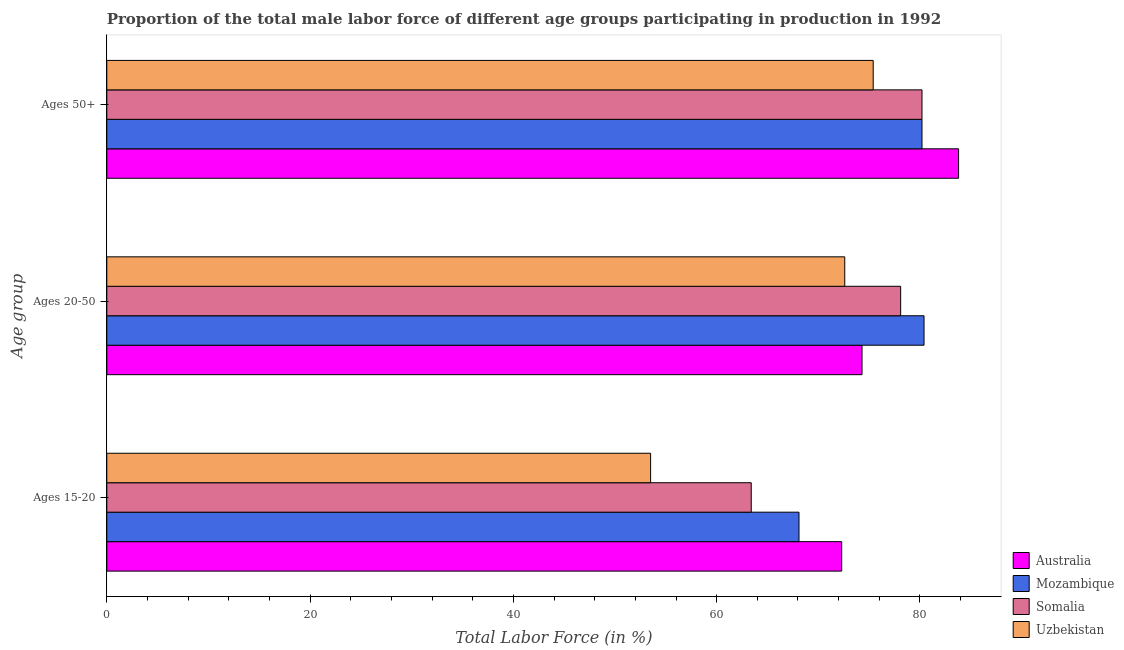How many different coloured bars are there?
Provide a succinct answer. 4. How many groups of bars are there?
Your answer should be very brief. 3. What is the label of the 3rd group of bars from the top?
Your answer should be compact. Ages 15-20. What is the percentage of male labor force above age 50 in Mozambique?
Offer a very short reply. 80.2. Across all countries, what is the maximum percentage of male labor force above age 50?
Your answer should be compact. 83.8. Across all countries, what is the minimum percentage of male labor force within the age group 20-50?
Provide a succinct answer. 72.6. In which country was the percentage of male labor force within the age group 20-50 maximum?
Provide a short and direct response. Mozambique. In which country was the percentage of male labor force within the age group 15-20 minimum?
Offer a terse response. Uzbekistan. What is the total percentage of male labor force within the age group 20-50 in the graph?
Provide a succinct answer. 305.4. What is the difference between the percentage of male labor force above age 50 in Uzbekistan and that in Australia?
Offer a terse response. -8.4. What is the difference between the percentage of male labor force within the age group 15-20 in Uzbekistan and the percentage of male labor force above age 50 in Mozambique?
Provide a succinct answer. -26.7. What is the average percentage of male labor force above age 50 per country?
Keep it short and to the point. 79.9. What is the difference between the percentage of male labor force above age 50 and percentage of male labor force within the age group 15-20 in Mozambique?
Your answer should be very brief. 12.1. In how many countries, is the percentage of male labor force above age 50 greater than 28 %?
Provide a succinct answer. 4. What is the ratio of the percentage of male labor force above age 50 in Mozambique to that in Australia?
Keep it short and to the point. 0.96. Is the percentage of male labor force within the age group 20-50 in Somalia less than that in Mozambique?
Give a very brief answer. Yes. Is the difference between the percentage of male labor force within the age group 15-20 in Australia and Mozambique greater than the difference between the percentage of male labor force above age 50 in Australia and Mozambique?
Give a very brief answer. Yes. What is the difference between the highest and the second highest percentage of male labor force above age 50?
Your response must be concise. 3.6. What is the difference between the highest and the lowest percentage of male labor force within the age group 15-20?
Give a very brief answer. 18.8. What does the 4th bar from the bottom in Ages 50+ represents?
Keep it short and to the point. Uzbekistan. Is it the case that in every country, the sum of the percentage of male labor force within the age group 15-20 and percentage of male labor force within the age group 20-50 is greater than the percentage of male labor force above age 50?
Ensure brevity in your answer.  Yes. How many bars are there?
Provide a short and direct response. 12. Are the values on the major ticks of X-axis written in scientific E-notation?
Your answer should be very brief. No. Does the graph contain any zero values?
Your answer should be compact. No. Does the graph contain grids?
Ensure brevity in your answer.  No. Where does the legend appear in the graph?
Give a very brief answer. Bottom right. How many legend labels are there?
Keep it short and to the point. 4. How are the legend labels stacked?
Your response must be concise. Vertical. What is the title of the graph?
Give a very brief answer. Proportion of the total male labor force of different age groups participating in production in 1992. Does "Turks and Caicos Islands" appear as one of the legend labels in the graph?
Offer a very short reply. No. What is the label or title of the Y-axis?
Make the answer very short. Age group. What is the Total Labor Force (in %) in Australia in Ages 15-20?
Provide a succinct answer. 72.3. What is the Total Labor Force (in %) in Mozambique in Ages 15-20?
Your response must be concise. 68.1. What is the Total Labor Force (in %) of Somalia in Ages 15-20?
Provide a succinct answer. 63.4. What is the Total Labor Force (in %) in Uzbekistan in Ages 15-20?
Make the answer very short. 53.5. What is the Total Labor Force (in %) in Australia in Ages 20-50?
Give a very brief answer. 74.3. What is the Total Labor Force (in %) in Mozambique in Ages 20-50?
Provide a short and direct response. 80.4. What is the Total Labor Force (in %) of Somalia in Ages 20-50?
Offer a terse response. 78.1. What is the Total Labor Force (in %) of Uzbekistan in Ages 20-50?
Provide a short and direct response. 72.6. What is the Total Labor Force (in %) in Australia in Ages 50+?
Your response must be concise. 83.8. What is the Total Labor Force (in %) of Mozambique in Ages 50+?
Keep it short and to the point. 80.2. What is the Total Labor Force (in %) in Somalia in Ages 50+?
Keep it short and to the point. 80.2. What is the Total Labor Force (in %) of Uzbekistan in Ages 50+?
Your answer should be very brief. 75.4. Across all Age group, what is the maximum Total Labor Force (in %) in Australia?
Your answer should be very brief. 83.8. Across all Age group, what is the maximum Total Labor Force (in %) of Mozambique?
Offer a terse response. 80.4. Across all Age group, what is the maximum Total Labor Force (in %) in Somalia?
Your answer should be compact. 80.2. Across all Age group, what is the maximum Total Labor Force (in %) of Uzbekistan?
Provide a succinct answer. 75.4. Across all Age group, what is the minimum Total Labor Force (in %) of Australia?
Offer a terse response. 72.3. Across all Age group, what is the minimum Total Labor Force (in %) in Mozambique?
Offer a very short reply. 68.1. Across all Age group, what is the minimum Total Labor Force (in %) of Somalia?
Provide a succinct answer. 63.4. Across all Age group, what is the minimum Total Labor Force (in %) in Uzbekistan?
Your response must be concise. 53.5. What is the total Total Labor Force (in %) of Australia in the graph?
Provide a succinct answer. 230.4. What is the total Total Labor Force (in %) of Mozambique in the graph?
Your response must be concise. 228.7. What is the total Total Labor Force (in %) of Somalia in the graph?
Your answer should be compact. 221.7. What is the total Total Labor Force (in %) in Uzbekistan in the graph?
Provide a short and direct response. 201.5. What is the difference between the Total Labor Force (in %) of Australia in Ages 15-20 and that in Ages 20-50?
Offer a terse response. -2. What is the difference between the Total Labor Force (in %) of Mozambique in Ages 15-20 and that in Ages 20-50?
Provide a short and direct response. -12.3. What is the difference between the Total Labor Force (in %) of Somalia in Ages 15-20 and that in Ages 20-50?
Make the answer very short. -14.7. What is the difference between the Total Labor Force (in %) in Uzbekistan in Ages 15-20 and that in Ages 20-50?
Your response must be concise. -19.1. What is the difference between the Total Labor Force (in %) in Australia in Ages 15-20 and that in Ages 50+?
Provide a succinct answer. -11.5. What is the difference between the Total Labor Force (in %) in Mozambique in Ages 15-20 and that in Ages 50+?
Give a very brief answer. -12.1. What is the difference between the Total Labor Force (in %) of Somalia in Ages 15-20 and that in Ages 50+?
Offer a very short reply. -16.8. What is the difference between the Total Labor Force (in %) in Uzbekistan in Ages 15-20 and that in Ages 50+?
Ensure brevity in your answer.  -21.9. What is the difference between the Total Labor Force (in %) in Somalia in Ages 20-50 and that in Ages 50+?
Provide a succinct answer. -2.1. What is the difference between the Total Labor Force (in %) of Uzbekistan in Ages 20-50 and that in Ages 50+?
Offer a terse response. -2.8. What is the difference between the Total Labor Force (in %) of Australia in Ages 15-20 and the Total Labor Force (in %) of Mozambique in Ages 20-50?
Ensure brevity in your answer.  -8.1. What is the difference between the Total Labor Force (in %) of Australia in Ages 15-20 and the Total Labor Force (in %) of Somalia in Ages 20-50?
Offer a terse response. -5.8. What is the difference between the Total Labor Force (in %) of Mozambique in Ages 15-20 and the Total Labor Force (in %) of Uzbekistan in Ages 20-50?
Ensure brevity in your answer.  -4.5. What is the difference between the Total Labor Force (in %) in Australia in Ages 15-20 and the Total Labor Force (in %) in Mozambique in Ages 50+?
Make the answer very short. -7.9. What is the difference between the Total Labor Force (in %) in Australia in Ages 15-20 and the Total Labor Force (in %) in Somalia in Ages 50+?
Provide a succinct answer. -7.9. What is the difference between the Total Labor Force (in %) of Australia in Ages 15-20 and the Total Labor Force (in %) of Uzbekistan in Ages 50+?
Your answer should be compact. -3.1. What is the difference between the Total Labor Force (in %) in Mozambique in Ages 15-20 and the Total Labor Force (in %) in Somalia in Ages 50+?
Your response must be concise. -12.1. What is the difference between the Total Labor Force (in %) in Mozambique in Ages 15-20 and the Total Labor Force (in %) in Uzbekistan in Ages 50+?
Ensure brevity in your answer.  -7.3. What is the difference between the Total Labor Force (in %) of Somalia in Ages 15-20 and the Total Labor Force (in %) of Uzbekistan in Ages 50+?
Your answer should be very brief. -12. What is the difference between the Total Labor Force (in %) of Mozambique in Ages 20-50 and the Total Labor Force (in %) of Somalia in Ages 50+?
Offer a very short reply. 0.2. What is the difference between the Total Labor Force (in %) of Somalia in Ages 20-50 and the Total Labor Force (in %) of Uzbekistan in Ages 50+?
Provide a short and direct response. 2.7. What is the average Total Labor Force (in %) in Australia per Age group?
Offer a terse response. 76.8. What is the average Total Labor Force (in %) in Mozambique per Age group?
Your answer should be very brief. 76.23. What is the average Total Labor Force (in %) in Somalia per Age group?
Give a very brief answer. 73.9. What is the average Total Labor Force (in %) of Uzbekistan per Age group?
Give a very brief answer. 67.17. What is the difference between the Total Labor Force (in %) in Mozambique and Total Labor Force (in %) in Somalia in Ages 15-20?
Provide a succinct answer. 4.7. What is the difference between the Total Labor Force (in %) in Australia and Total Labor Force (in %) in Uzbekistan in Ages 20-50?
Your response must be concise. 1.7. What is the difference between the Total Labor Force (in %) in Mozambique and Total Labor Force (in %) in Uzbekistan in Ages 20-50?
Give a very brief answer. 7.8. What is the difference between the Total Labor Force (in %) of Somalia and Total Labor Force (in %) of Uzbekistan in Ages 20-50?
Give a very brief answer. 5.5. What is the difference between the Total Labor Force (in %) in Australia and Total Labor Force (in %) in Mozambique in Ages 50+?
Your response must be concise. 3.6. What is the difference between the Total Labor Force (in %) of Australia and Total Labor Force (in %) of Somalia in Ages 50+?
Your response must be concise. 3.6. What is the difference between the Total Labor Force (in %) of Mozambique and Total Labor Force (in %) of Somalia in Ages 50+?
Give a very brief answer. 0. What is the ratio of the Total Labor Force (in %) of Australia in Ages 15-20 to that in Ages 20-50?
Make the answer very short. 0.97. What is the ratio of the Total Labor Force (in %) of Mozambique in Ages 15-20 to that in Ages 20-50?
Give a very brief answer. 0.85. What is the ratio of the Total Labor Force (in %) of Somalia in Ages 15-20 to that in Ages 20-50?
Offer a very short reply. 0.81. What is the ratio of the Total Labor Force (in %) in Uzbekistan in Ages 15-20 to that in Ages 20-50?
Make the answer very short. 0.74. What is the ratio of the Total Labor Force (in %) of Australia in Ages 15-20 to that in Ages 50+?
Provide a short and direct response. 0.86. What is the ratio of the Total Labor Force (in %) in Mozambique in Ages 15-20 to that in Ages 50+?
Ensure brevity in your answer.  0.85. What is the ratio of the Total Labor Force (in %) of Somalia in Ages 15-20 to that in Ages 50+?
Your response must be concise. 0.79. What is the ratio of the Total Labor Force (in %) of Uzbekistan in Ages 15-20 to that in Ages 50+?
Provide a short and direct response. 0.71. What is the ratio of the Total Labor Force (in %) of Australia in Ages 20-50 to that in Ages 50+?
Provide a short and direct response. 0.89. What is the ratio of the Total Labor Force (in %) of Mozambique in Ages 20-50 to that in Ages 50+?
Provide a succinct answer. 1. What is the ratio of the Total Labor Force (in %) in Somalia in Ages 20-50 to that in Ages 50+?
Your response must be concise. 0.97. What is the ratio of the Total Labor Force (in %) in Uzbekistan in Ages 20-50 to that in Ages 50+?
Make the answer very short. 0.96. What is the difference between the highest and the second highest Total Labor Force (in %) in Australia?
Give a very brief answer. 9.5. What is the difference between the highest and the second highest Total Labor Force (in %) in Mozambique?
Provide a short and direct response. 0.2. What is the difference between the highest and the second highest Total Labor Force (in %) of Somalia?
Give a very brief answer. 2.1. What is the difference between the highest and the second highest Total Labor Force (in %) in Uzbekistan?
Keep it short and to the point. 2.8. What is the difference between the highest and the lowest Total Labor Force (in %) in Australia?
Give a very brief answer. 11.5. What is the difference between the highest and the lowest Total Labor Force (in %) in Somalia?
Make the answer very short. 16.8. What is the difference between the highest and the lowest Total Labor Force (in %) of Uzbekistan?
Provide a succinct answer. 21.9. 